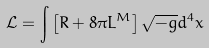<formula> <loc_0><loc_0><loc_500><loc_500>\mathcal { L } = \int \left [ R + 8 \pi L ^ { M } \right ] \sqrt { - g } d ^ { 4 } x</formula> 